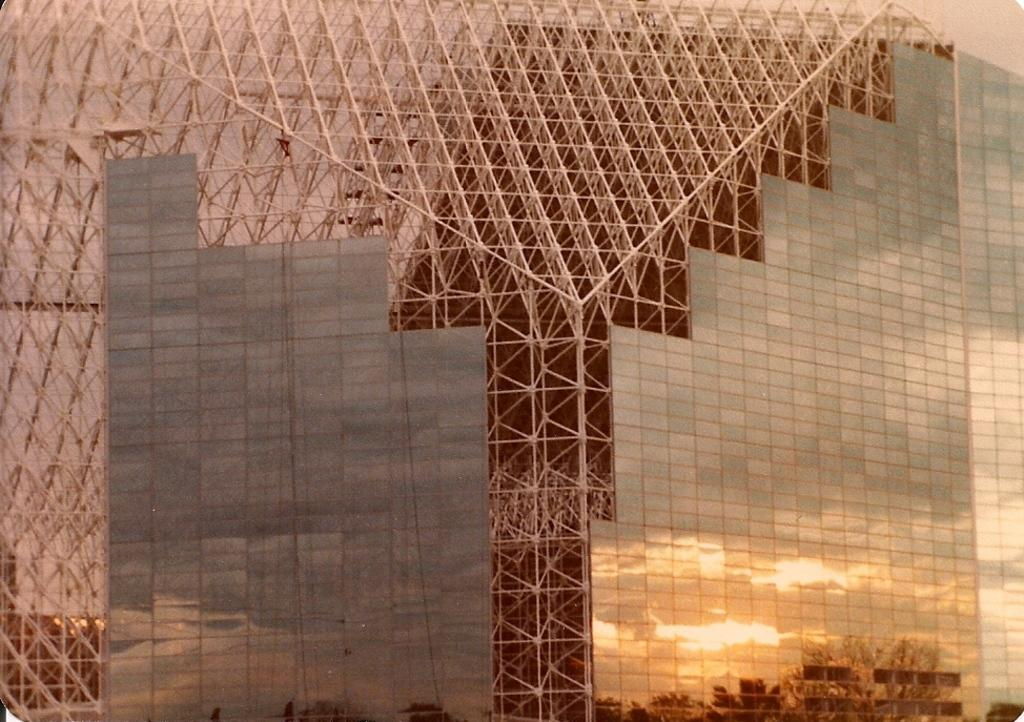What type of objects are made of metal in the image? There are metal rods in the image. What can be seen in the image that is used for drinking? There are glasses in the image. What object in the image allows for reflection? There is a mirror in the image. What is visible in the mirror's reflection? The mirror reflection shows trees. How many dolls are sitting on the metal rods in the image? There are no dolls present in the image; it features metal rods, glasses, and a mirror. What type of orange is visible in the mirror's reflection? There is no orange visible in the mirror's reflection; it shows trees. 